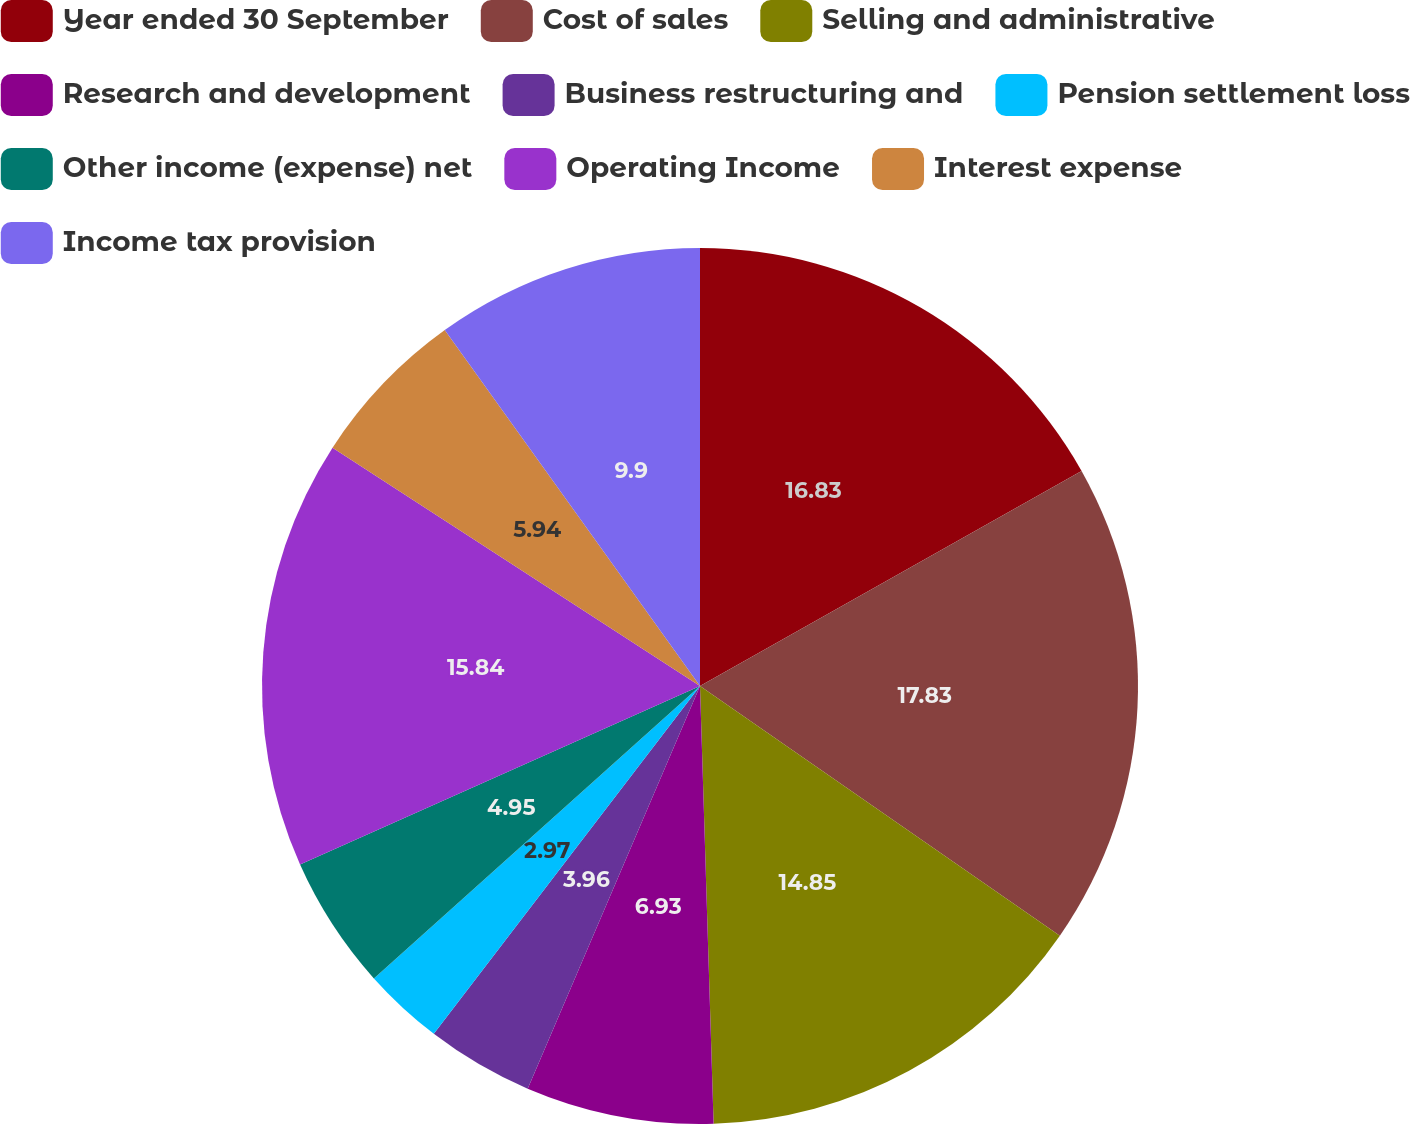Convert chart to OTSL. <chart><loc_0><loc_0><loc_500><loc_500><pie_chart><fcel>Year ended 30 September<fcel>Cost of sales<fcel>Selling and administrative<fcel>Research and development<fcel>Business restructuring and<fcel>Pension settlement loss<fcel>Other income (expense) net<fcel>Operating Income<fcel>Interest expense<fcel>Income tax provision<nl><fcel>16.83%<fcel>17.82%<fcel>14.85%<fcel>6.93%<fcel>3.96%<fcel>2.97%<fcel>4.95%<fcel>15.84%<fcel>5.94%<fcel>9.9%<nl></chart> 